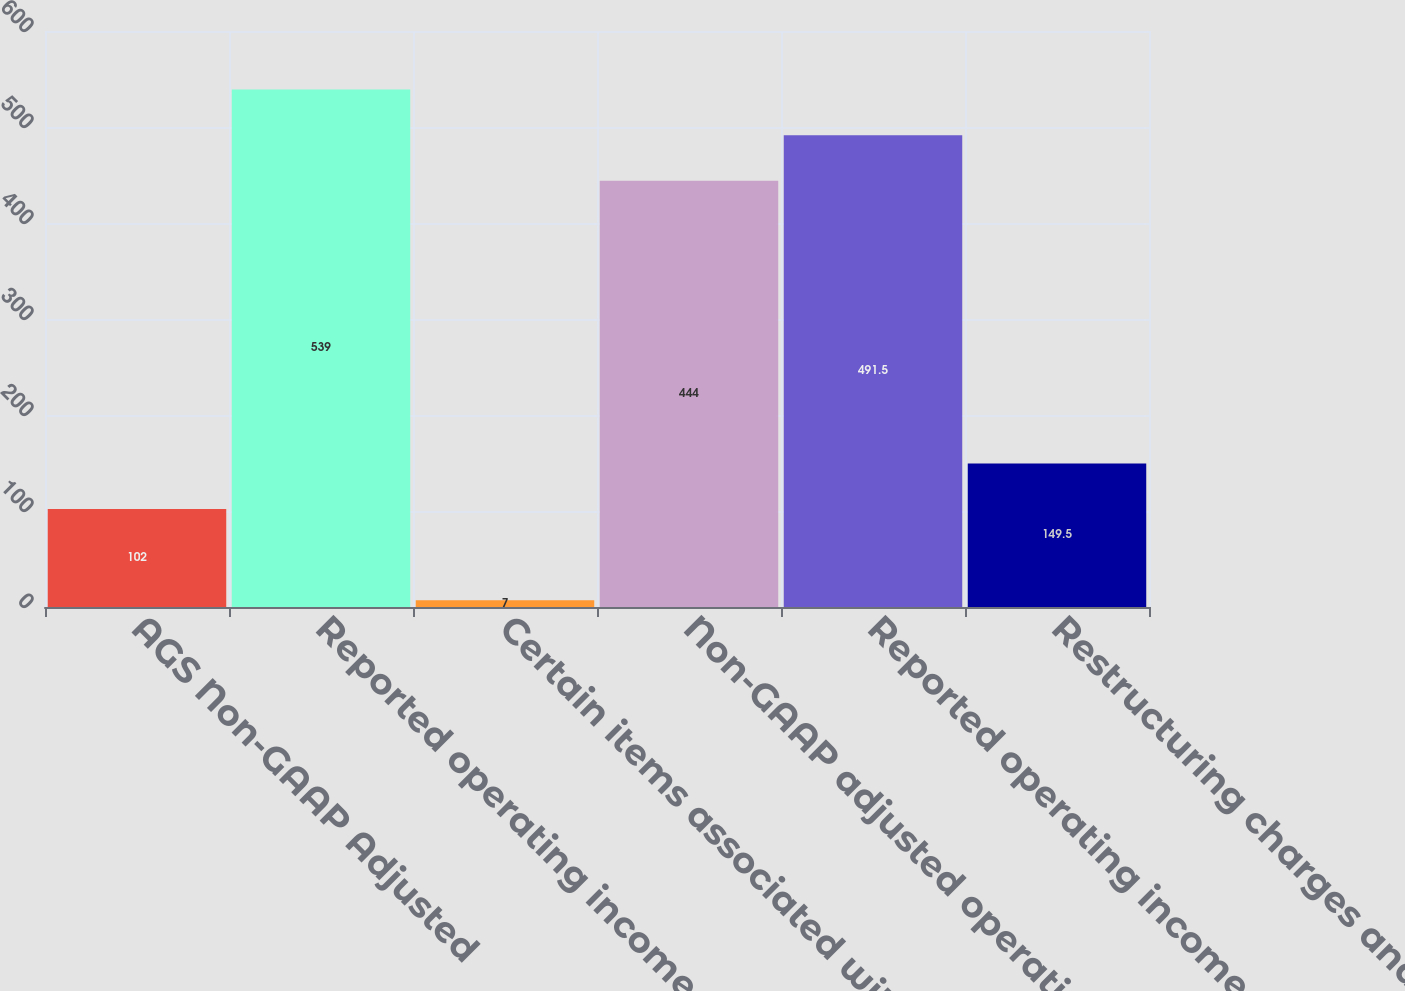Convert chart. <chart><loc_0><loc_0><loc_500><loc_500><bar_chart><fcel>AGS Non-GAAP Adjusted<fcel>Reported operating income -<fcel>Certain items associated with<fcel>Non-GAAP adjusted operating<fcel>Reported operating income<fcel>Restructuring charges and<nl><fcel>102<fcel>539<fcel>7<fcel>444<fcel>491.5<fcel>149.5<nl></chart> 